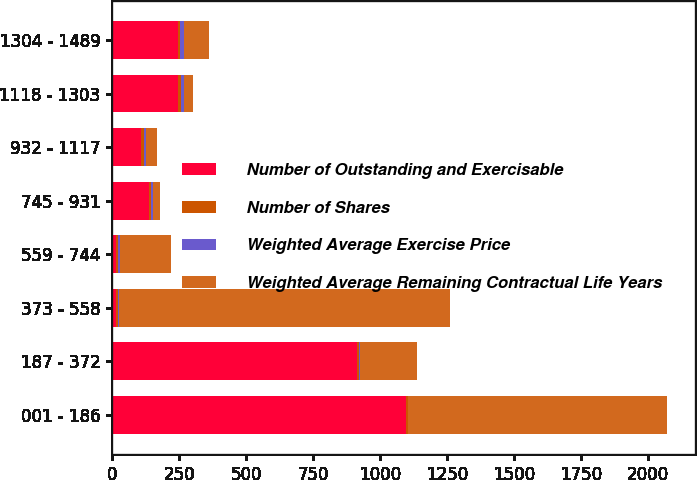<chart> <loc_0><loc_0><loc_500><loc_500><stacked_bar_chart><ecel><fcel>001 - 186<fcel>187 - 372<fcel>373 - 558<fcel>559 - 744<fcel>745 - 931<fcel>932 - 1117<fcel>1118 - 1303<fcel>1304 - 1489<nl><fcel>Number of Outstanding and Exercisable<fcel>1097<fcel>914<fcel>13.18<fcel>13.18<fcel>137<fcel>109<fcel>246<fcel>245<nl><fcel>Number of Shares<fcel>6.7<fcel>8.7<fcel>8.2<fcel>9.1<fcel>8.7<fcel>8.3<fcel>9.6<fcel>9.7<nl><fcel>Weighted Average Exercise Price<fcel>0.87<fcel>2.66<fcel>4.79<fcel>6.17<fcel>8.02<fcel>10.06<fcel>12.39<fcel>13.97<nl><fcel>Weighted Average Remaining Contractual Life Years<fcel>966<fcel>214<fcel>1236<fcel>191<fcel>24<fcel>40<fcel>32<fcel>92<nl></chart> 